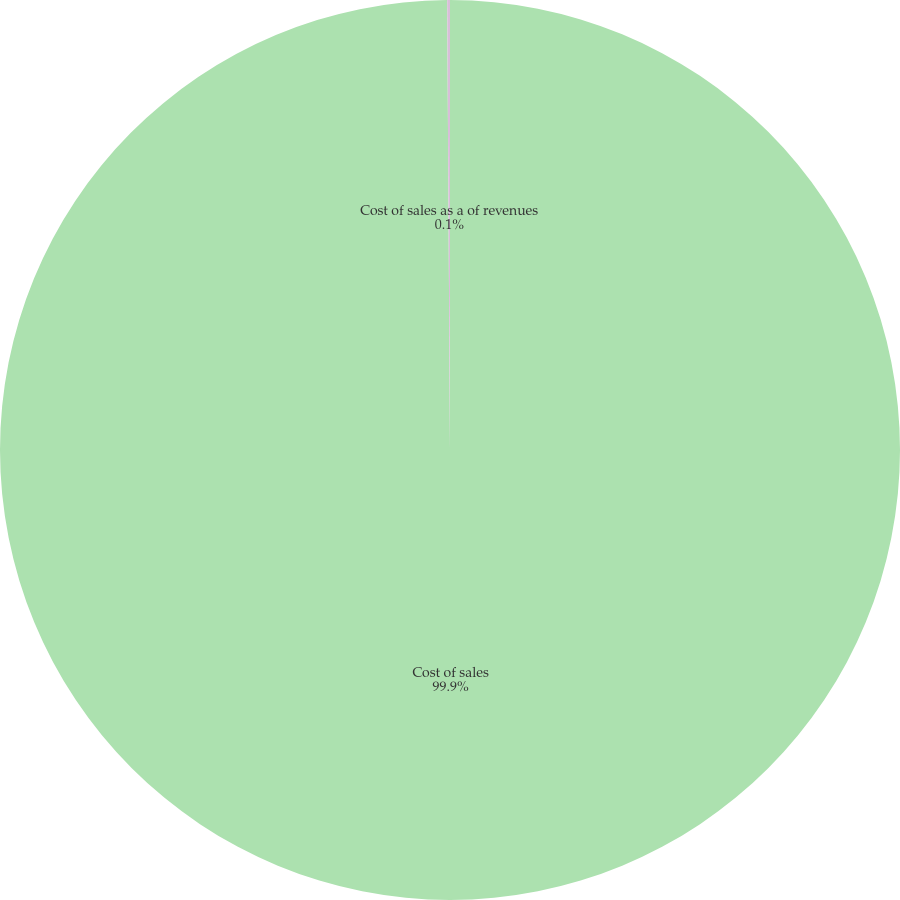Convert chart. <chart><loc_0><loc_0><loc_500><loc_500><pie_chart><fcel>Cost of sales<fcel>Cost of sales as a of revenues<nl><fcel>99.9%<fcel>0.1%<nl></chart> 